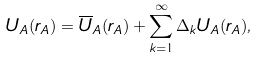<formula> <loc_0><loc_0><loc_500><loc_500>U _ { A } ( r _ { A } ) = \overline { U } _ { A } ( r _ { A } ) + \sum _ { k = 1 } ^ { \infty } \Delta _ { k } U _ { A } ( r _ { A } ) ,</formula> 